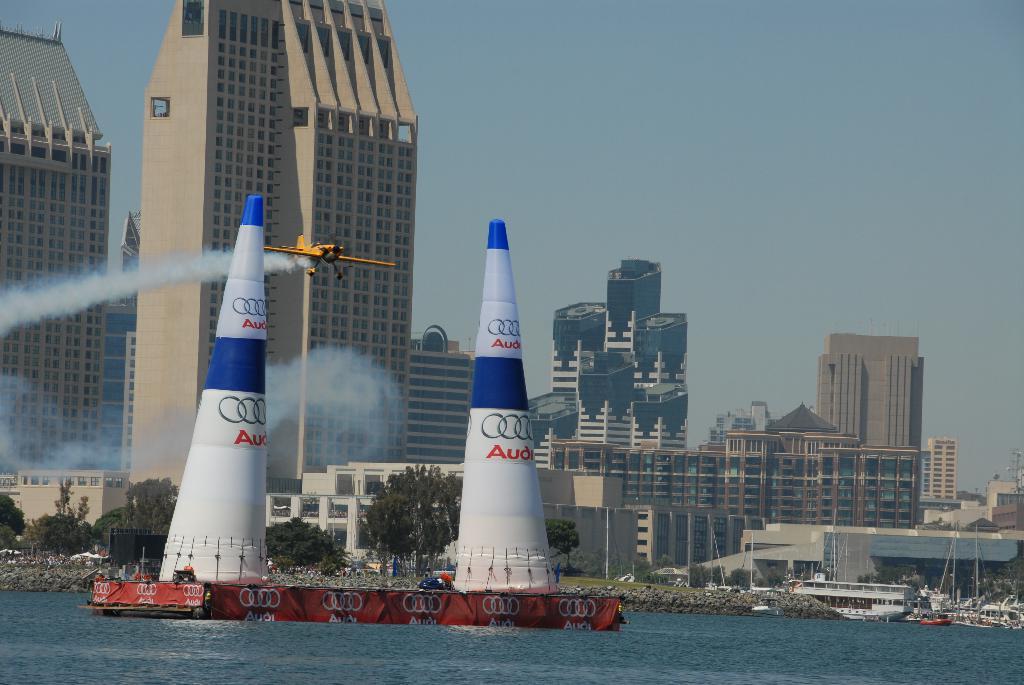Could you give a brief overview of what you see in this image? In this picture I can see there is a ship sailing on the water and in the backdrop I can see there are some other ships and boats on to right side and there are trees, buildings in the backdrop. 